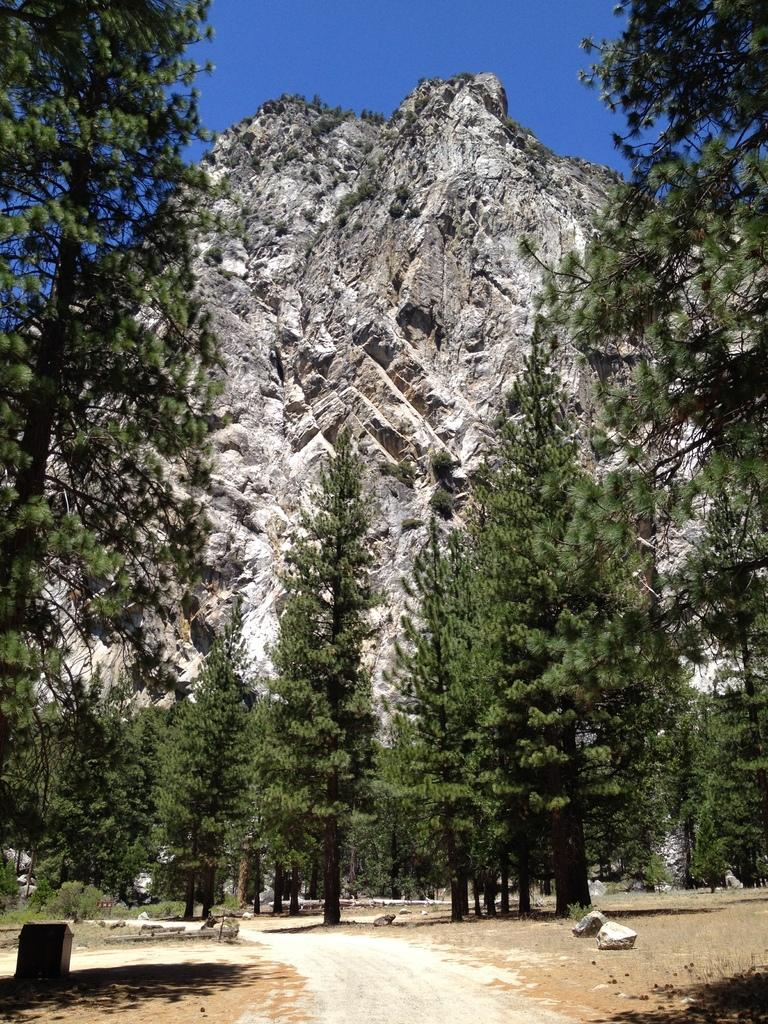What type of natural features can be seen in the image? There are rocks, trees, and a mountain in the image. How many trees are visible in the image? There are many trees in the image. What is the background of the image? The sky is visible in the background of the image. What color is the sky in the image? The sky appears to be blue in the image. Where are the beds located in the image? There are no beds present in the image. What type of boundary can be seen between the mountain and the sky? There is no boundary visible between the mountain and the sky in the image. 